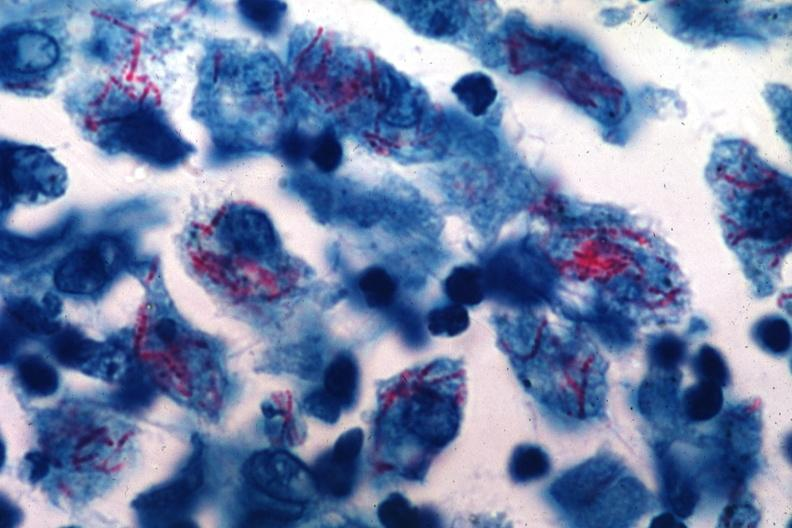what stain many intracellular bacterial this probably was an early case of mycobacterium intracellulare infection too many organisms for old time tb?
Answer the question using a single word or phrase. Acid 